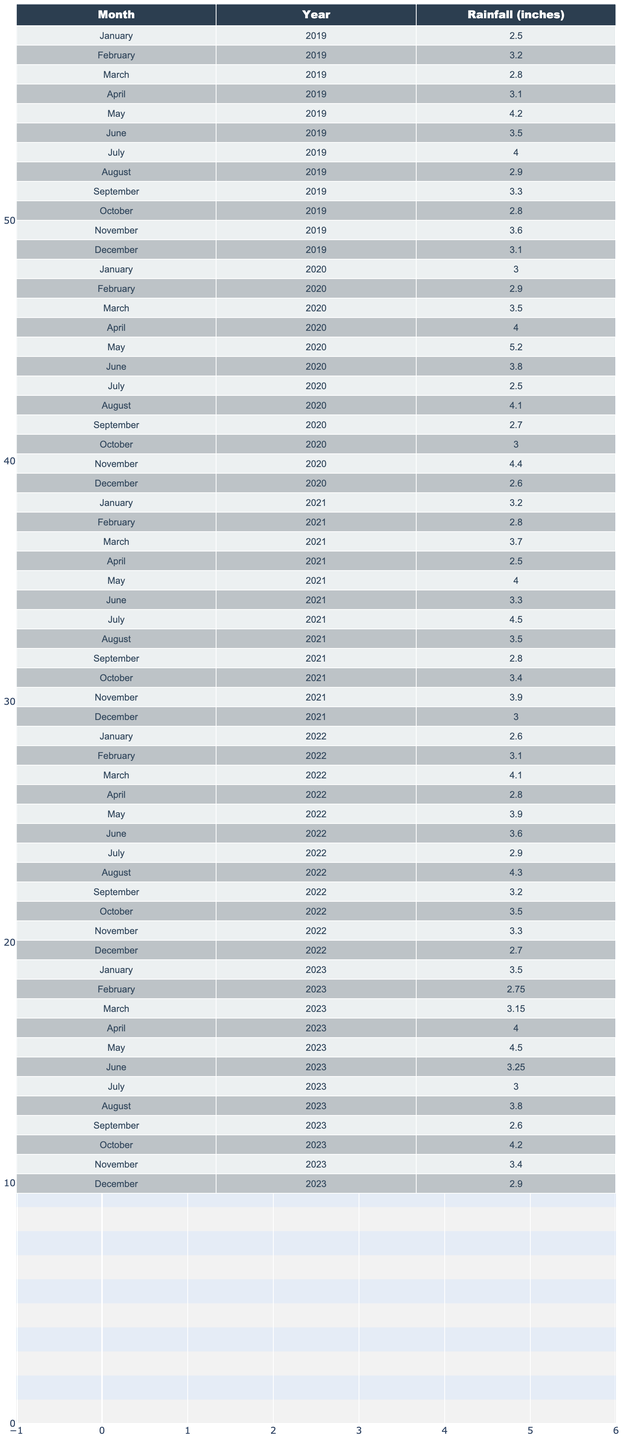What was the total rainfall for Hurlock, Maryland in July 2020? From the table, July 2020 has a rainfall of 2.50 inches. Therefore, the total rainfall for that month is simply the value listed, which is 2.50 inches.
Answer: 2.50 inches What was the average rainfall in Hurlock, Maryland during the month of March over the five years? For March, the rainfall amounts over five years are (2.80 + 3.50 + 3.70 + 4.10 + 3.15). Adding these gives a total of 17.25 inches. Dividing this total by 5 gives an average of 17.25 / 5 = 3.45 inches.
Answer: 3.45 inches Was there more rainfall in August or September 2021 in Hurlock, Maryland? In August 2021, the rainfall was 3.50 inches, while in September 2021, it was 2.80 inches. Since 3.50 is greater than 2.80, there was more rainfall in August than in September 2021.
Answer: Yes What month in 2022 had the highest rainfall, and what was that amount? Looking through the months in 2022, the maximum rainfall is found in August 2022, which recorded 4.30 inches. Therefore, August has the highest rainfall for that year at 4.30 inches.
Answer: August, 4.30 inches What is the total rainfall recorded for Hurlock, Maryland in the year 2020? To find the total rainfall for 2020, we add the monthly rainfall: (3.00 + 2.90 + 3.50 + 4.00 + 5.20 + 3.80 + 2.50 + 4.10 + 2.70 + 3.00 + 4.40 + 2.60) = 43.50 inches. Thus, the total rainfall for the year 2020 is 43.50 inches.
Answer: 43.50 inches During which year did Hurlock, Maryland experience the highest recorded rainfall in December? By analyzing the data for December across the years, we observe that December 2020 recorded 2.60 inches, while December 2021 recorded 3.00 inches, and December 2022 recorded 2.70 inches. Since 3.00 inches is the highest, it occurred in December 2021.
Answer: 2021 What was the percentage increase in rainfall from May 2022 to May 2023 in Hurlock, Maryland? The rainfall in May 2022 was 3.90 inches and in May 2023 it was 4.50 inches. The increase in rainfall is 4.50 - 3.90 = 0.60 inches. The percentage increase is (0.60 / 3.90) * 100 = 15.38%.
Answer: 15.38% In which month across all years did Hurlock experience the lowest recorded rainfall, and what was that value? Reviewing the records, the lowest recorded rainfall is found in July 2020 with only 2.50 inches. Therefore, this month had the lowest recorded rainfall in all the years presented.
Answer: July 2020, 2.50 inches Was the average monthly rainfall in the first half of 2021 greater than 3 inches? For the first half of 2021, the monthly rainfall values are January (3.20), February (2.80), March (3.70), April (2.50), May (4.00), and June (3.30). The total is 3.20 + 2.80 + 3.70 + 2.50 + 4.00 + 3.30 = 19.50 inches. The average is 19.50 / 6 = 3.25 inches, which is greater than 3 inches.
Answer: Yes What is the difference in average rainfall between June 2022 and June 2023 in Hurlock? The rainfall for June 2022 is 3.60 inches and for June 2023, it is 3.25 inches. The difference is 3.60 - 3.25 = 0.35 inches, meaning June 2022 had 0.35 inches more rainfall than June 2023.
Answer: 0.35 inches 